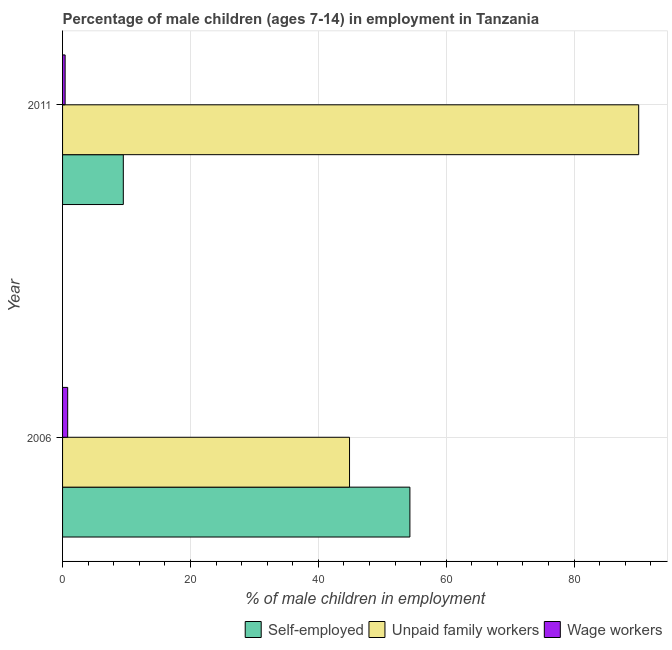How many different coloured bars are there?
Keep it short and to the point. 3. How many bars are there on the 2nd tick from the top?
Your answer should be compact. 3. What is the percentage of children employed as unpaid family workers in 2011?
Your answer should be very brief. 90.1. Across all years, what is the minimum percentage of children employed as wage workers?
Give a very brief answer. 0.4. What is the total percentage of self employed children in the graph?
Your answer should be compact. 63.82. What is the difference between the percentage of self employed children in 2006 and that in 2011?
Make the answer very short. 44.82. What is the difference between the percentage of children employed as unpaid family workers in 2006 and the percentage of children employed as wage workers in 2011?
Provide a succinct answer. 44.48. What is the average percentage of children employed as unpaid family workers per year?
Provide a short and direct response. 67.49. In the year 2011, what is the difference between the percentage of children employed as unpaid family workers and percentage of children employed as wage workers?
Keep it short and to the point. 89.7. What is the ratio of the percentage of children employed as unpaid family workers in 2006 to that in 2011?
Your response must be concise. 0.5. In how many years, is the percentage of self employed children greater than the average percentage of self employed children taken over all years?
Ensure brevity in your answer.  1. What does the 2nd bar from the top in 2011 represents?
Keep it short and to the point. Unpaid family workers. What does the 2nd bar from the bottom in 2006 represents?
Your answer should be very brief. Unpaid family workers. Are the values on the major ticks of X-axis written in scientific E-notation?
Your answer should be compact. No. Where does the legend appear in the graph?
Offer a very short reply. Bottom right. How many legend labels are there?
Make the answer very short. 3. How are the legend labels stacked?
Provide a succinct answer. Horizontal. What is the title of the graph?
Make the answer very short. Percentage of male children (ages 7-14) in employment in Tanzania. Does "Ages 20-50" appear as one of the legend labels in the graph?
Keep it short and to the point. No. What is the label or title of the X-axis?
Make the answer very short. % of male children in employment. What is the % of male children in employment of Self-employed in 2006?
Provide a short and direct response. 54.32. What is the % of male children in employment in Unpaid family workers in 2006?
Your answer should be very brief. 44.88. What is the % of male children in employment in Wage workers in 2006?
Your answer should be compact. 0.8. What is the % of male children in employment in Unpaid family workers in 2011?
Offer a terse response. 90.1. Across all years, what is the maximum % of male children in employment in Self-employed?
Ensure brevity in your answer.  54.32. Across all years, what is the maximum % of male children in employment in Unpaid family workers?
Provide a succinct answer. 90.1. Across all years, what is the maximum % of male children in employment in Wage workers?
Offer a very short reply. 0.8. Across all years, what is the minimum % of male children in employment in Self-employed?
Give a very brief answer. 9.5. Across all years, what is the minimum % of male children in employment of Unpaid family workers?
Your answer should be compact. 44.88. What is the total % of male children in employment in Self-employed in the graph?
Your answer should be compact. 63.82. What is the total % of male children in employment in Unpaid family workers in the graph?
Your answer should be very brief. 134.98. What is the difference between the % of male children in employment of Self-employed in 2006 and that in 2011?
Offer a terse response. 44.82. What is the difference between the % of male children in employment in Unpaid family workers in 2006 and that in 2011?
Give a very brief answer. -45.22. What is the difference between the % of male children in employment of Self-employed in 2006 and the % of male children in employment of Unpaid family workers in 2011?
Offer a very short reply. -35.78. What is the difference between the % of male children in employment in Self-employed in 2006 and the % of male children in employment in Wage workers in 2011?
Your answer should be compact. 53.92. What is the difference between the % of male children in employment of Unpaid family workers in 2006 and the % of male children in employment of Wage workers in 2011?
Provide a succinct answer. 44.48. What is the average % of male children in employment in Self-employed per year?
Your answer should be compact. 31.91. What is the average % of male children in employment in Unpaid family workers per year?
Offer a terse response. 67.49. What is the average % of male children in employment in Wage workers per year?
Keep it short and to the point. 0.6. In the year 2006, what is the difference between the % of male children in employment of Self-employed and % of male children in employment of Unpaid family workers?
Make the answer very short. 9.44. In the year 2006, what is the difference between the % of male children in employment of Self-employed and % of male children in employment of Wage workers?
Offer a terse response. 53.52. In the year 2006, what is the difference between the % of male children in employment of Unpaid family workers and % of male children in employment of Wage workers?
Offer a very short reply. 44.08. In the year 2011, what is the difference between the % of male children in employment in Self-employed and % of male children in employment in Unpaid family workers?
Your answer should be very brief. -80.6. In the year 2011, what is the difference between the % of male children in employment of Unpaid family workers and % of male children in employment of Wage workers?
Your answer should be compact. 89.7. What is the ratio of the % of male children in employment in Self-employed in 2006 to that in 2011?
Provide a short and direct response. 5.72. What is the ratio of the % of male children in employment in Unpaid family workers in 2006 to that in 2011?
Your answer should be very brief. 0.5. What is the ratio of the % of male children in employment of Wage workers in 2006 to that in 2011?
Offer a very short reply. 2. What is the difference between the highest and the second highest % of male children in employment in Self-employed?
Keep it short and to the point. 44.82. What is the difference between the highest and the second highest % of male children in employment of Unpaid family workers?
Your response must be concise. 45.22. What is the difference between the highest and the lowest % of male children in employment of Self-employed?
Provide a short and direct response. 44.82. What is the difference between the highest and the lowest % of male children in employment of Unpaid family workers?
Give a very brief answer. 45.22. What is the difference between the highest and the lowest % of male children in employment in Wage workers?
Ensure brevity in your answer.  0.4. 